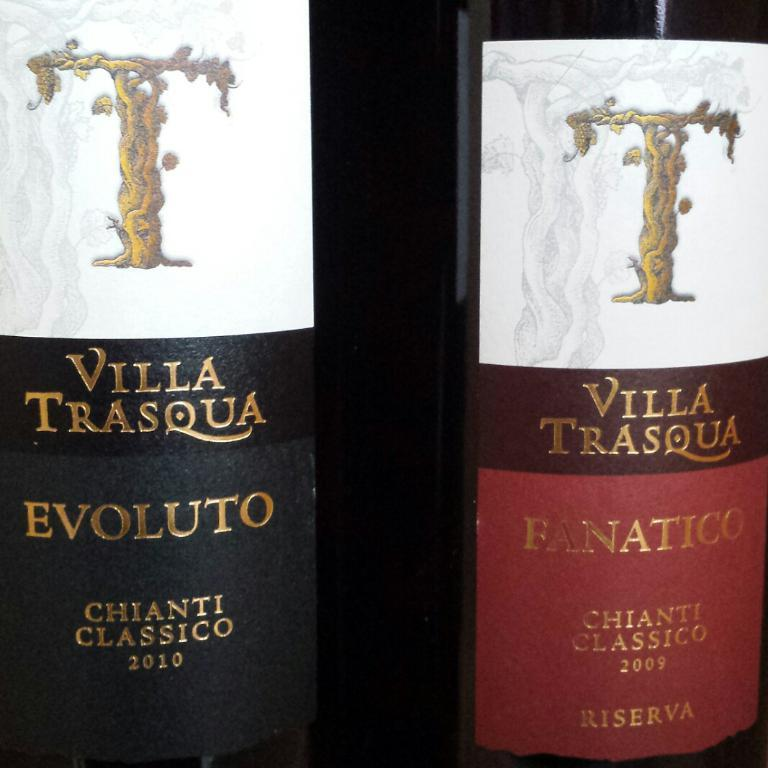<image>
Create a compact narrative representing the image presented. Two bottles of Villa Trasqua wine stand side by side each other. 